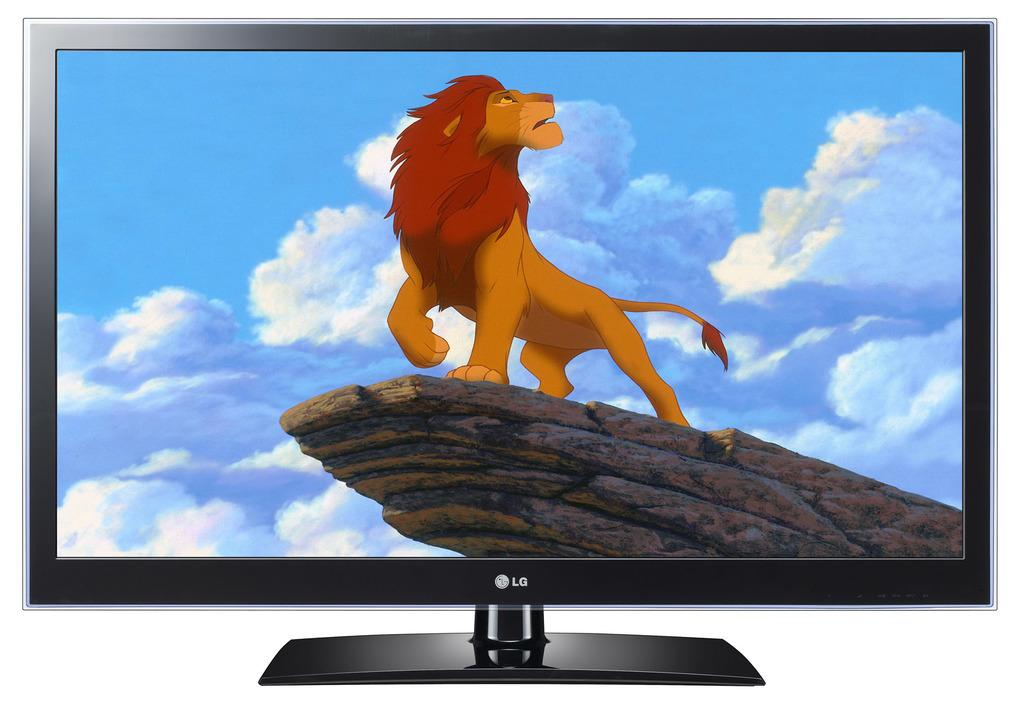<image>
Present a compact description of the photo's key features. An LG TV with a scene from The Lion King on it. 